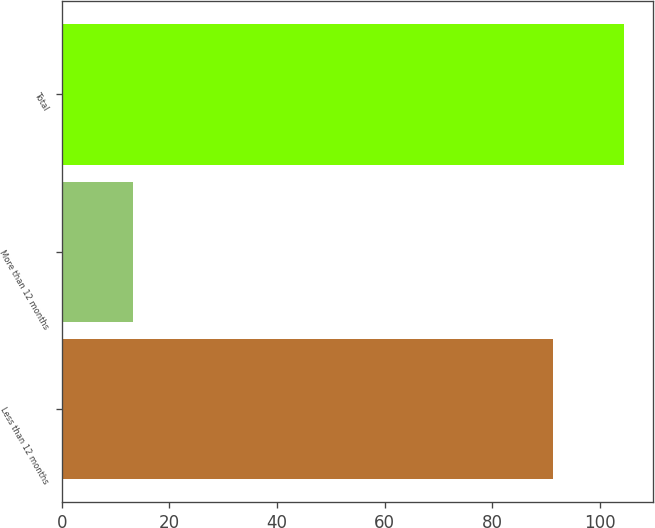Convert chart to OTSL. <chart><loc_0><loc_0><loc_500><loc_500><bar_chart><fcel>Less than 12 months<fcel>More than 12 months<fcel>Total<nl><fcel>91.4<fcel>13.2<fcel>104.6<nl></chart> 